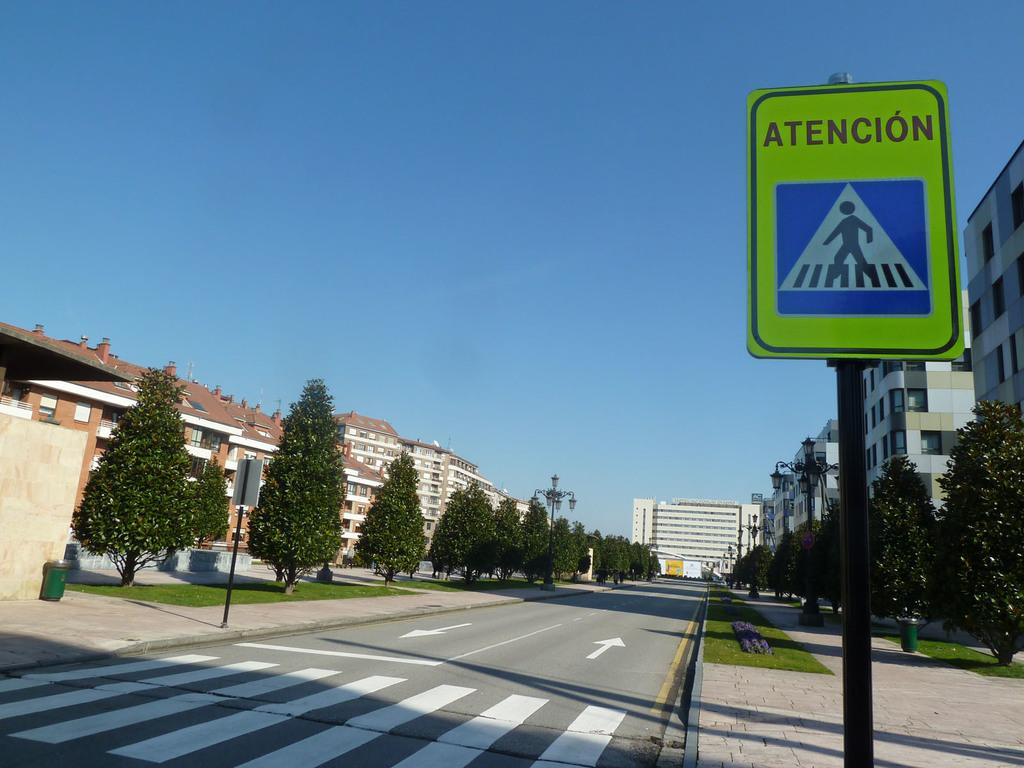<image>
Present a compact description of the photo's key features. A crosswalk has a sign on the right that displays Atencion. 